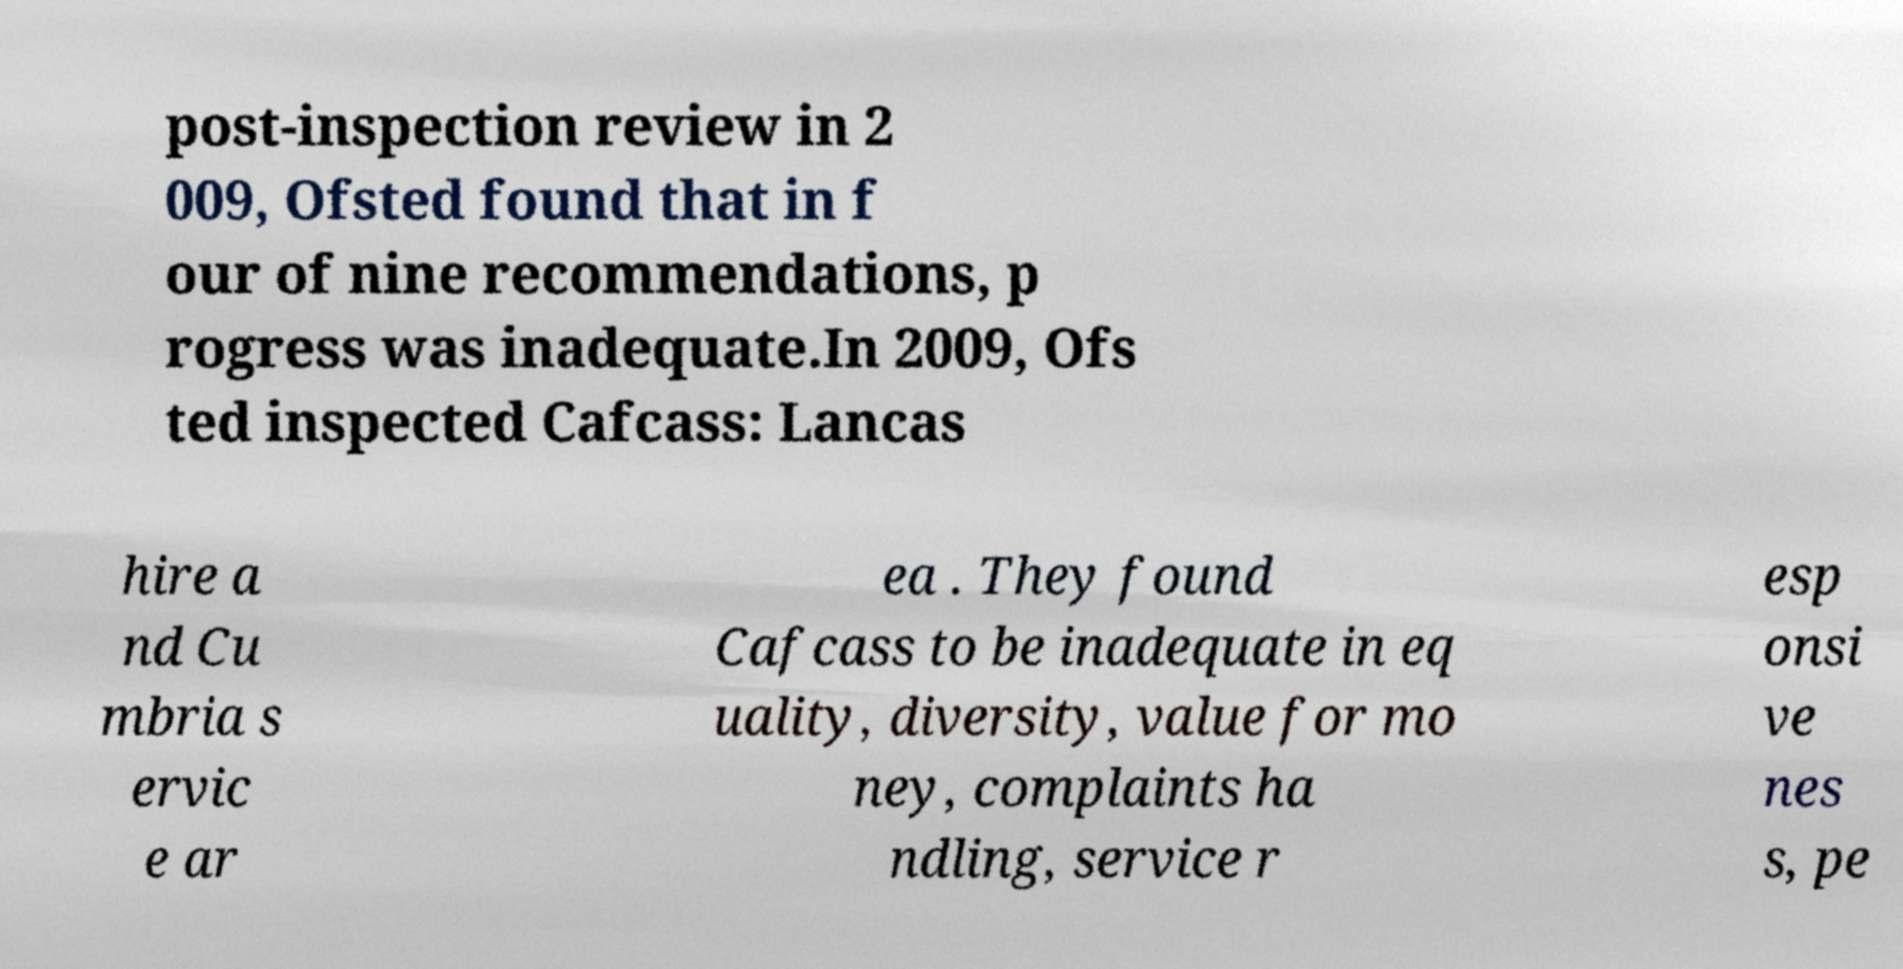What messages or text are displayed in this image? I need them in a readable, typed format. post-inspection review in 2 009, Ofsted found that in f our of nine recommendations, p rogress was inadequate.In 2009, Ofs ted inspected Cafcass: Lancas hire a nd Cu mbria s ervic e ar ea . They found Cafcass to be inadequate in eq uality, diversity, value for mo ney, complaints ha ndling, service r esp onsi ve nes s, pe 